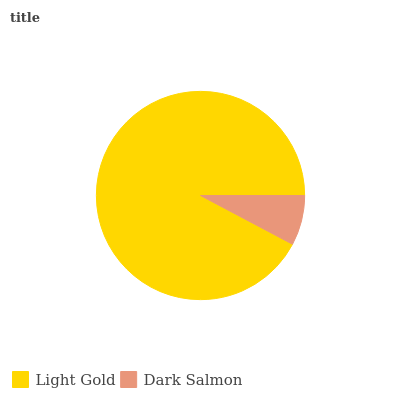Is Dark Salmon the minimum?
Answer yes or no. Yes. Is Light Gold the maximum?
Answer yes or no. Yes. Is Dark Salmon the maximum?
Answer yes or no. No. Is Light Gold greater than Dark Salmon?
Answer yes or no. Yes. Is Dark Salmon less than Light Gold?
Answer yes or no. Yes. Is Dark Salmon greater than Light Gold?
Answer yes or no. No. Is Light Gold less than Dark Salmon?
Answer yes or no. No. Is Light Gold the high median?
Answer yes or no. Yes. Is Dark Salmon the low median?
Answer yes or no. Yes. Is Dark Salmon the high median?
Answer yes or no. No. Is Light Gold the low median?
Answer yes or no. No. 